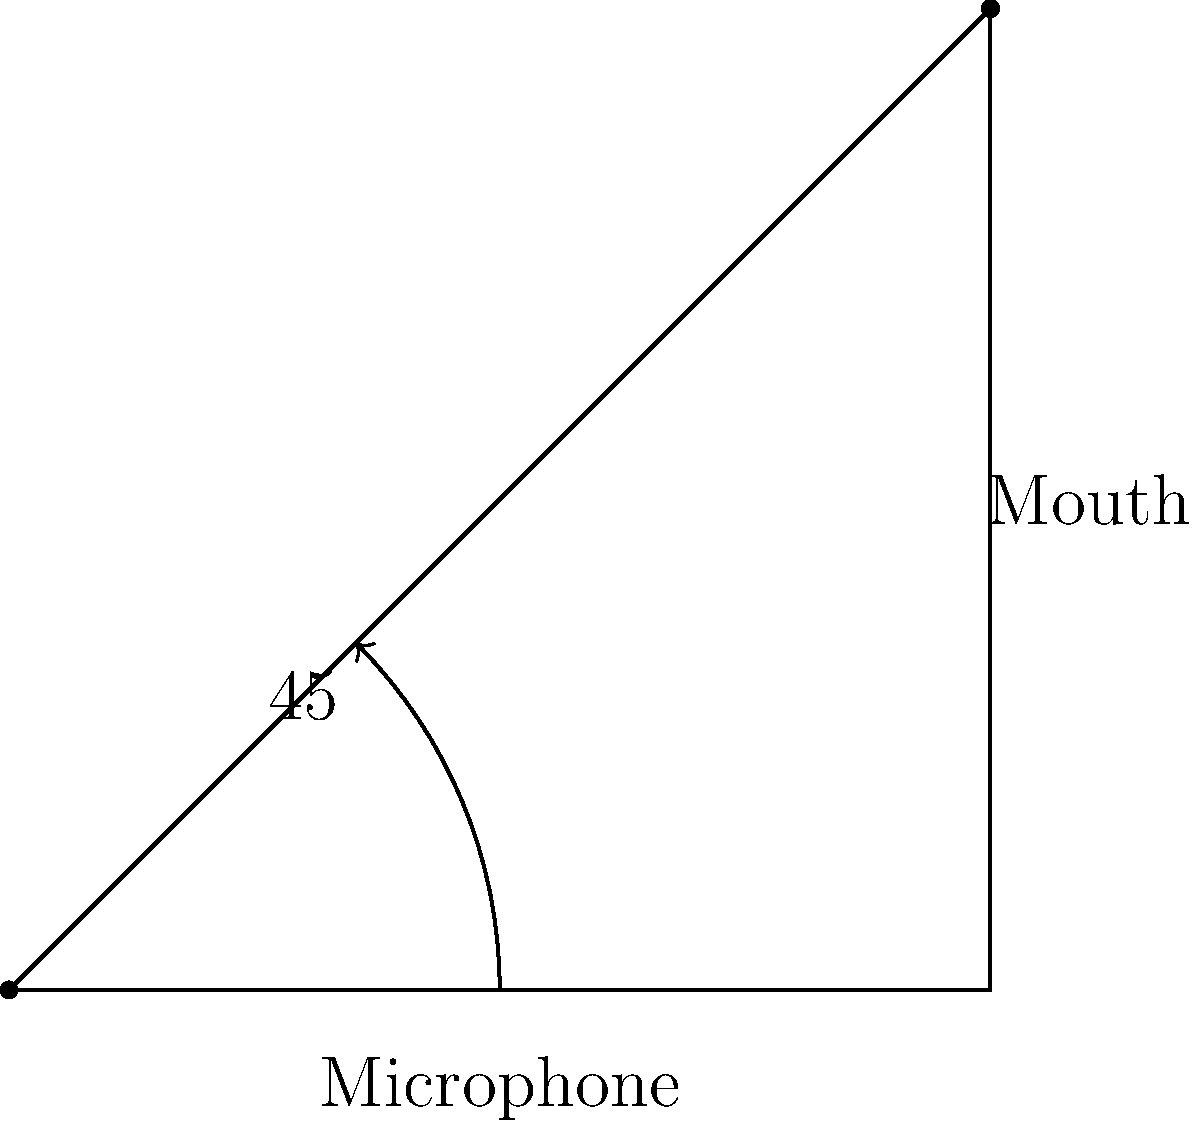During a live performance, what is the optimal angle at which you should hold your microphone to ensure the best sound quality and minimize feedback? To determine the optimal angle for holding a microphone during a performance, we need to consider several factors:

1. Sound projection: The microphone needs to be positioned to capture the sound waves from your mouth effectively.

2. Feedback prevention: Holding the microphone at the wrong angle can increase the risk of feedback from nearby speakers.

3. Proximity effect: The closer the microphone is to your mouth, the more bass frequencies are emphasized.

4. Comfort and mobility: The angle should allow for comfortable holding and easy movement during your performance.

Considering these factors, the optimal angle for holding a microphone is approximately 45 degrees from the vertical axis. This angle provides:

1. Effective sound capture: At 45 degrees, the microphone is well-positioned to pick up your voice without obstructing your mouth.

2. Reduced feedback: This angle helps minimize the pickup of sound from monitors or speakers, reducing the risk of feedback.

3. Balanced frequency response: The 45-degree angle allows for a good balance between proximity effect and overall sound quality.

4. Comfortable grip: This angle is natural and comfortable for most performers, allowing for easy movement and gestures during the performance.

5. Visual appeal: The 45-degree angle looks professional and allows the audience to see your face clearly.

It's important to note that while 45 degrees is generally considered optimal, slight adjustments may be necessary depending on your individual vocal style, the specific microphone being used, and the acoustics of the performance space.
Answer: 45 degrees 